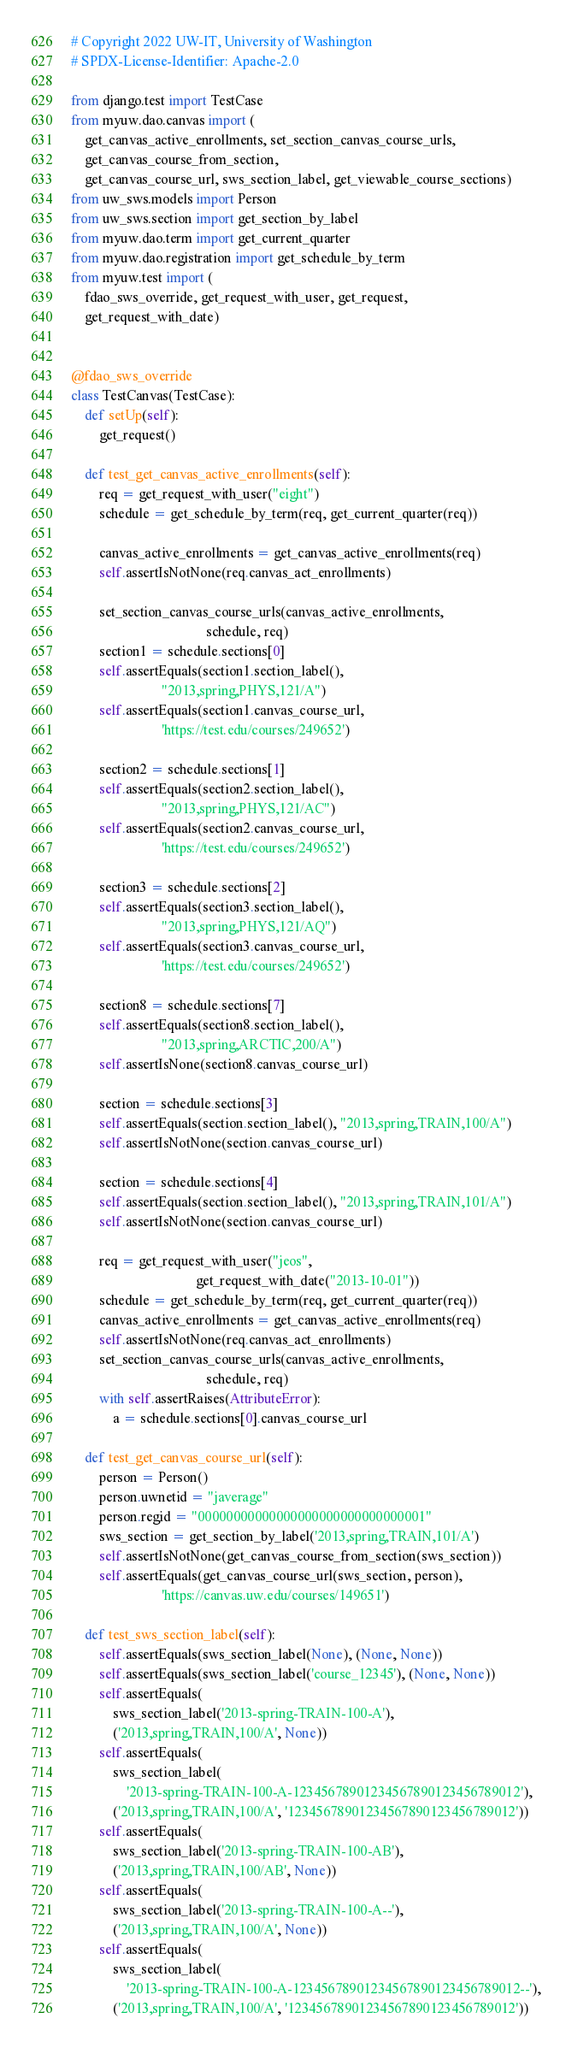Convert code to text. <code><loc_0><loc_0><loc_500><loc_500><_Python_># Copyright 2022 UW-IT, University of Washington
# SPDX-License-Identifier: Apache-2.0

from django.test import TestCase
from myuw.dao.canvas import (
    get_canvas_active_enrollments, set_section_canvas_course_urls,
    get_canvas_course_from_section,
    get_canvas_course_url, sws_section_label, get_viewable_course_sections)
from uw_sws.models import Person
from uw_sws.section import get_section_by_label
from myuw.dao.term import get_current_quarter
from myuw.dao.registration import get_schedule_by_term
from myuw.test import (
    fdao_sws_override, get_request_with_user, get_request,
    get_request_with_date)


@fdao_sws_override
class TestCanvas(TestCase):
    def setUp(self):
        get_request()

    def test_get_canvas_active_enrollments(self):
        req = get_request_with_user("eight")
        schedule = get_schedule_by_term(req, get_current_quarter(req))

        canvas_active_enrollments = get_canvas_active_enrollments(req)
        self.assertIsNotNone(req.canvas_act_enrollments)

        set_section_canvas_course_urls(canvas_active_enrollments,
                                       schedule, req)
        section1 = schedule.sections[0]
        self.assertEquals(section1.section_label(),
                          "2013,spring,PHYS,121/A")
        self.assertEquals(section1.canvas_course_url,
                          'https://test.edu/courses/249652')

        section2 = schedule.sections[1]
        self.assertEquals(section2.section_label(),
                          "2013,spring,PHYS,121/AC")
        self.assertEquals(section2.canvas_course_url,
                          'https://test.edu/courses/249652')

        section3 = schedule.sections[2]
        self.assertEquals(section3.section_label(),
                          "2013,spring,PHYS,121/AQ")
        self.assertEquals(section3.canvas_course_url,
                          'https://test.edu/courses/249652')

        section8 = schedule.sections[7]
        self.assertEquals(section8.section_label(),
                          "2013,spring,ARCTIC,200/A")
        self.assertIsNone(section8.canvas_course_url)

        section = schedule.sections[3]
        self.assertEquals(section.section_label(), "2013,spring,TRAIN,100/A")
        self.assertIsNotNone(section.canvas_course_url)

        section = schedule.sections[4]
        self.assertEquals(section.section_label(), "2013,spring,TRAIN,101/A")
        self.assertIsNotNone(section.canvas_course_url)

        req = get_request_with_user("jeos",
                                    get_request_with_date("2013-10-01"))
        schedule = get_schedule_by_term(req, get_current_quarter(req))
        canvas_active_enrollments = get_canvas_active_enrollments(req)
        self.assertIsNotNone(req.canvas_act_enrollments)
        set_section_canvas_course_urls(canvas_active_enrollments,
                                       schedule, req)
        with self.assertRaises(AttributeError):
            a = schedule.sections[0].canvas_course_url

    def test_get_canvas_course_url(self):
        person = Person()
        person.uwnetid = "javerage"
        person.regid = "00000000000000000000000000000001"
        sws_section = get_section_by_label('2013,spring,TRAIN,101/A')
        self.assertIsNotNone(get_canvas_course_from_section(sws_section))
        self.assertEquals(get_canvas_course_url(sws_section, person),
                          'https://canvas.uw.edu/courses/149651')

    def test_sws_section_label(self):
        self.assertEquals(sws_section_label(None), (None, None))
        self.assertEquals(sws_section_label('course_12345'), (None, None))
        self.assertEquals(
            sws_section_label('2013-spring-TRAIN-100-A'),
            ('2013,spring,TRAIN,100/A', None))
        self.assertEquals(
            sws_section_label(
                '2013-spring-TRAIN-100-A-12345678901234567890123456789012'),
            ('2013,spring,TRAIN,100/A', '12345678901234567890123456789012'))
        self.assertEquals(
            sws_section_label('2013-spring-TRAIN-100-AB'),
            ('2013,spring,TRAIN,100/AB', None))
        self.assertEquals(
            sws_section_label('2013-spring-TRAIN-100-A--'),
            ('2013,spring,TRAIN,100/A', None))
        self.assertEquals(
            sws_section_label(
                '2013-spring-TRAIN-100-A-12345678901234567890123456789012--'),
            ('2013,spring,TRAIN,100/A', '12345678901234567890123456789012'))
</code> 